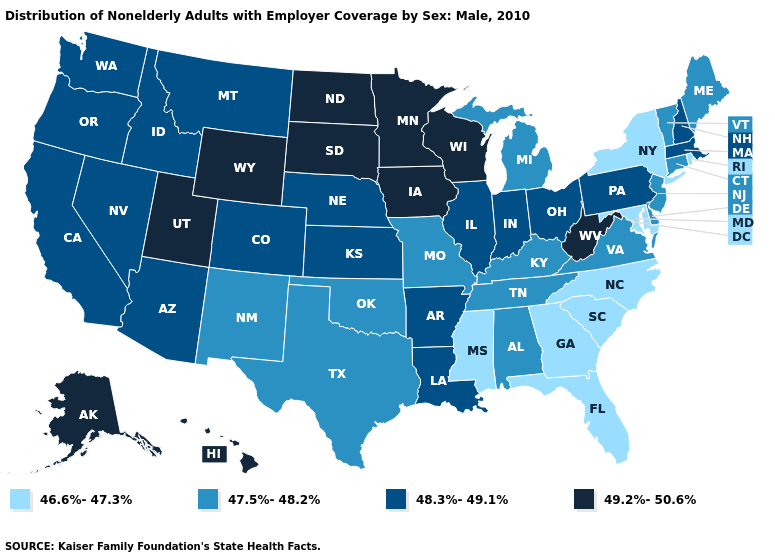How many symbols are there in the legend?
Answer briefly. 4. What is the value of Indiana?
Write a very short answer. 48.3%-49.1%. Name the states that have a value in the range 46.6%-47.3%?
Quick response, please. Florida, Georgia, Maryland, Mississippi, New York, North Carolina, Rhode Island, South Carolina. Does the map have missing data?
Answer briefly. No. Which states hav the highest value in the Northeast?
Give a very brief answer. Massachusetts, New Hampshire, Pennsylvania. What is the highest value in states that border Florida?
Write a very short answer. 47.5%-48.2%. What is the lowest value in the West?
Concise answer only. 47.5%-48.2%. What is the lowest value in the MidWest?
Concise answer only. 47.5%-48.2%. Among the states that border New Jersey , does Delaware have the lowest value?
Concise answer only. No. Does Michigan have the lowest value in the MidWest?
Quick response, please. Yes. Name the states that have a value in the range 47.5%-48.2%?
Quick response, please. Alabama, Connecticut, Delaware, Kentucky, Maine, Michigan, Missouri, New Jersey, New Mexico, Oklahoma, Tennessee, Texas, Vermont, Virginia. What is the value of Mississippi?
Be succinct. 46.6%-47.3%. How many symbols are there in the legend?
Concise answer only. 4. Does New Mexico have the lowest value in the West?
Answer briefly. Yes. Does the map have missing data?
Keep it brief. No. 